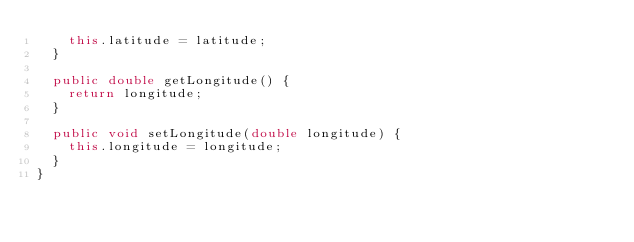<code> <loc_0><loc_0><loc_500><loc_500><_Java_>		this.latitude = latitude;
	}

	public double getLongitude() {
		return longitude;
	}

	public void setLongitude(double longitude) {
		this.longitude = longitude;
	}
}
</code> 